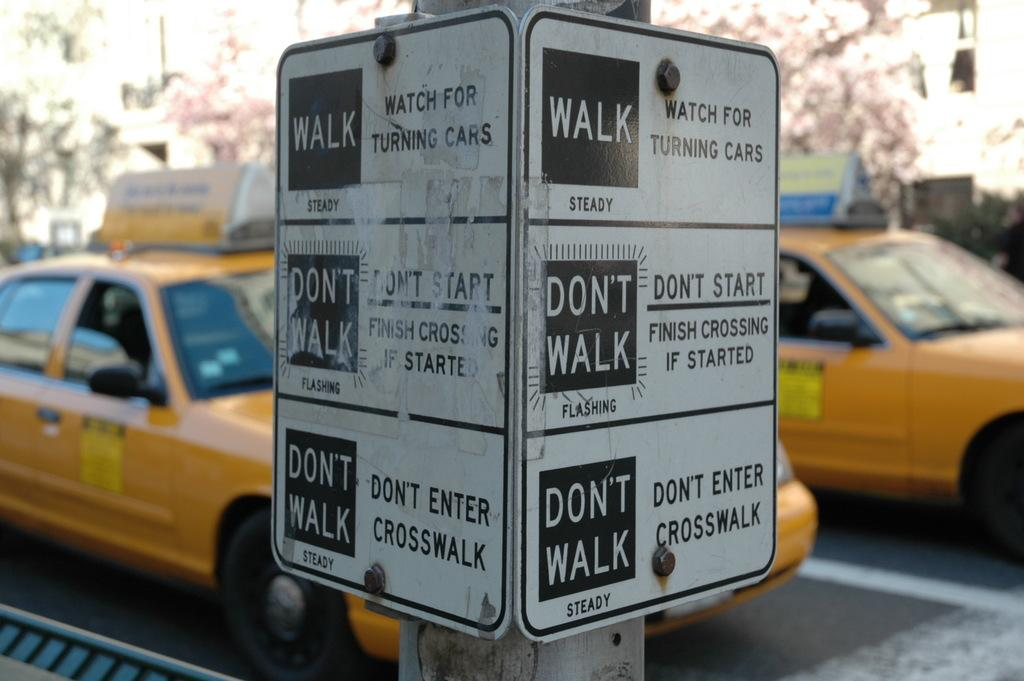<image>
Describe the image concisely. A sign posted at a coss walk indicating a pedestrian should walk or not walk depending on the sign displayed at if the light is steady or flashing. 